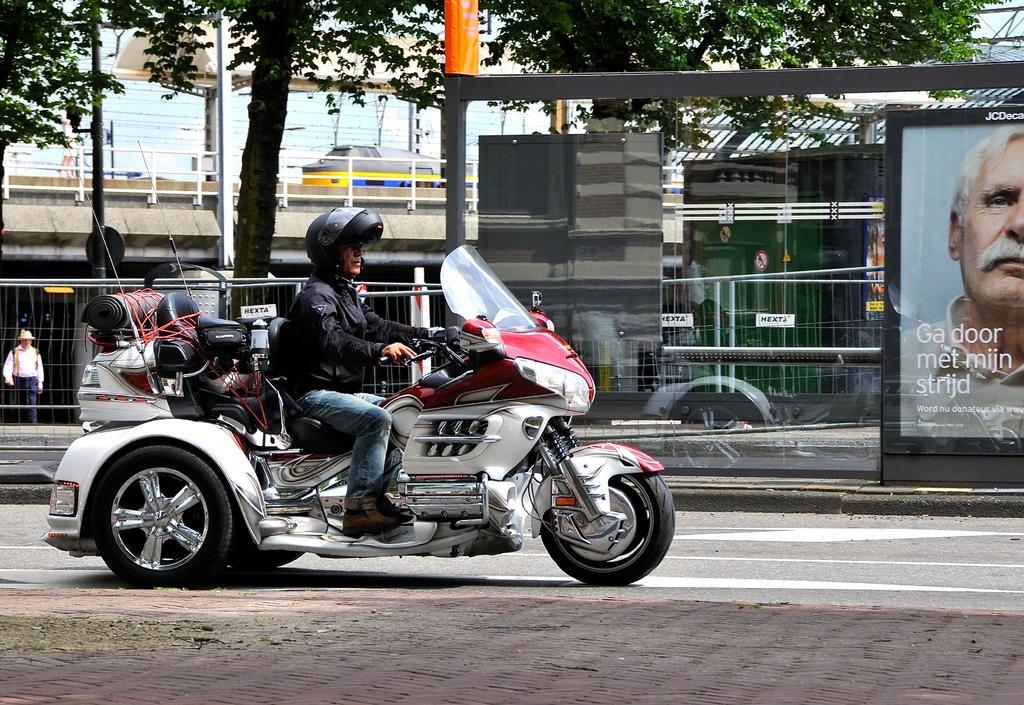Please provide a concise description of this image. This picture describes about a man riding a motorcycle on the road besides to him we can see a hoarding, building, a train and couple of trees. 